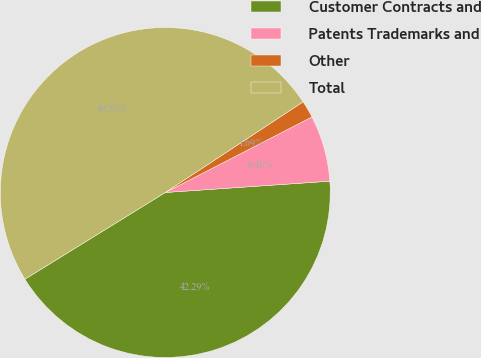<chart> <loc_0><loc_0><loc_500><loc_500><pie_chart><fcel>Customer Contracts and<fcel>Patents Trademarks and<fcel>Other<fcel>Total<nl><fcel>42.29%<fcel>6.48%<fcel>1.69%<fcel>49.55%<nl></chart> 